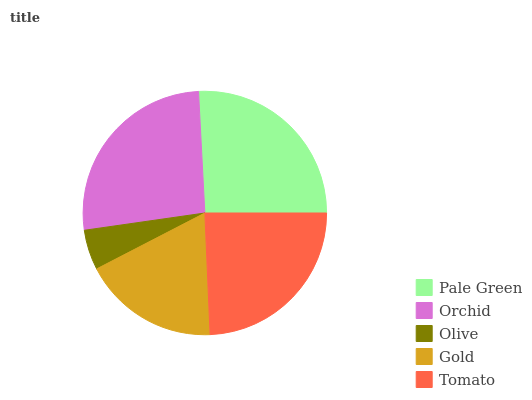Is Olive the minimum?
Answer yes or no. Yes. Is Orchid the maximum?
Answer yes or no. Yes. Is Orchid the minimum?
Answer yes or no. No. Is Olive the maximum?
Answer yes or no. No. Is Orchid greater than Olive?
Answer yes or no. Yes. Is Olive less than Orchid?
Answer yes or no. Yes. Is Olive greater than Orchid?
Answer yes or no. No. Is Orchid less than Olive?
Answer yes or no. No. Is Tomato the high median?
Answer yes or no. Yes. Is Tomato the low median?
Answer yes or no. Yes. Is Gold the high median?
Answer yes or no. No. Is Pale Green the low median?
Answer yes or no. No. 